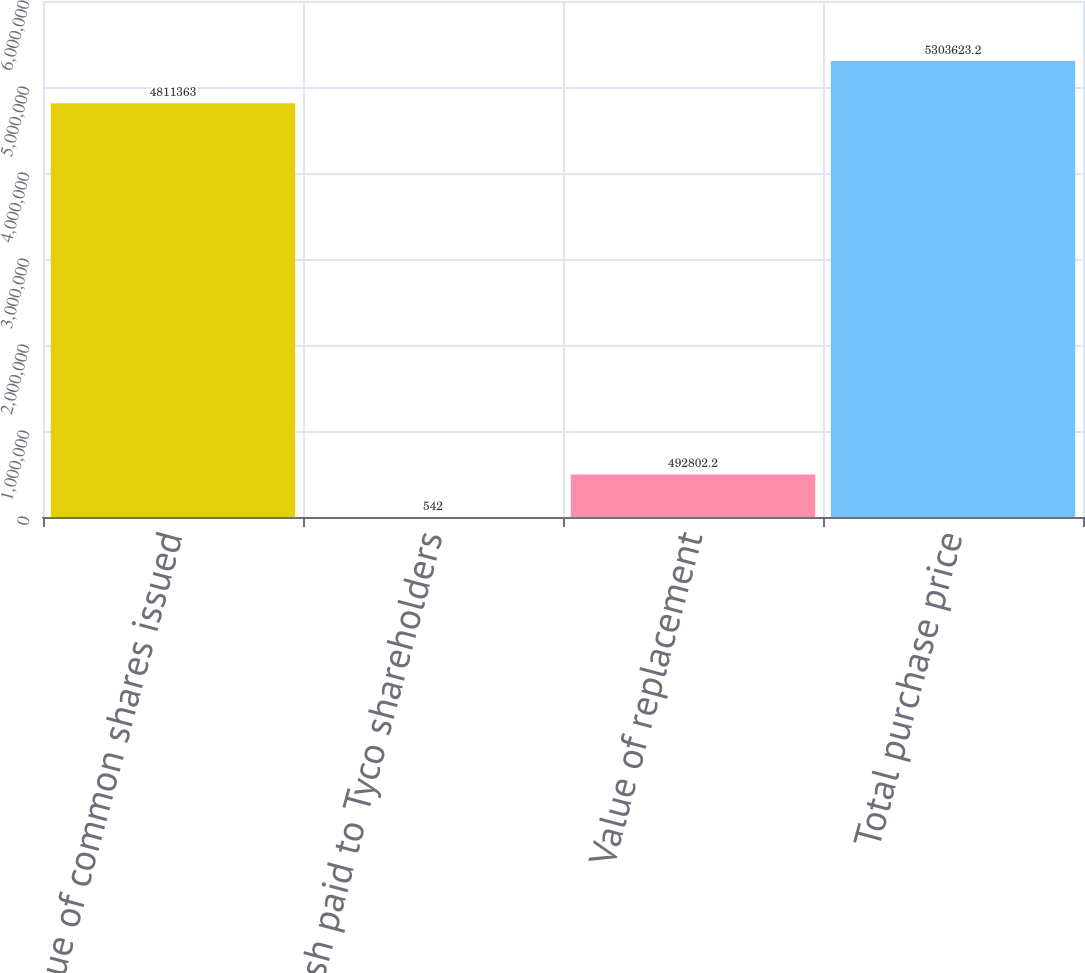Convert chart to OTSL. <chart><loc_0><loc_0><loc_500><loc_500><bar_chart><fcel>Value of common shares issued<fcel>Cash paid to Tyco shareholders<fcel>Value of replacement<fcel>Total purchase price<nl><fcel>4.81136e+06<fcel>542<fcel>492802<fcel>5.30362e+06<nl></chart> 